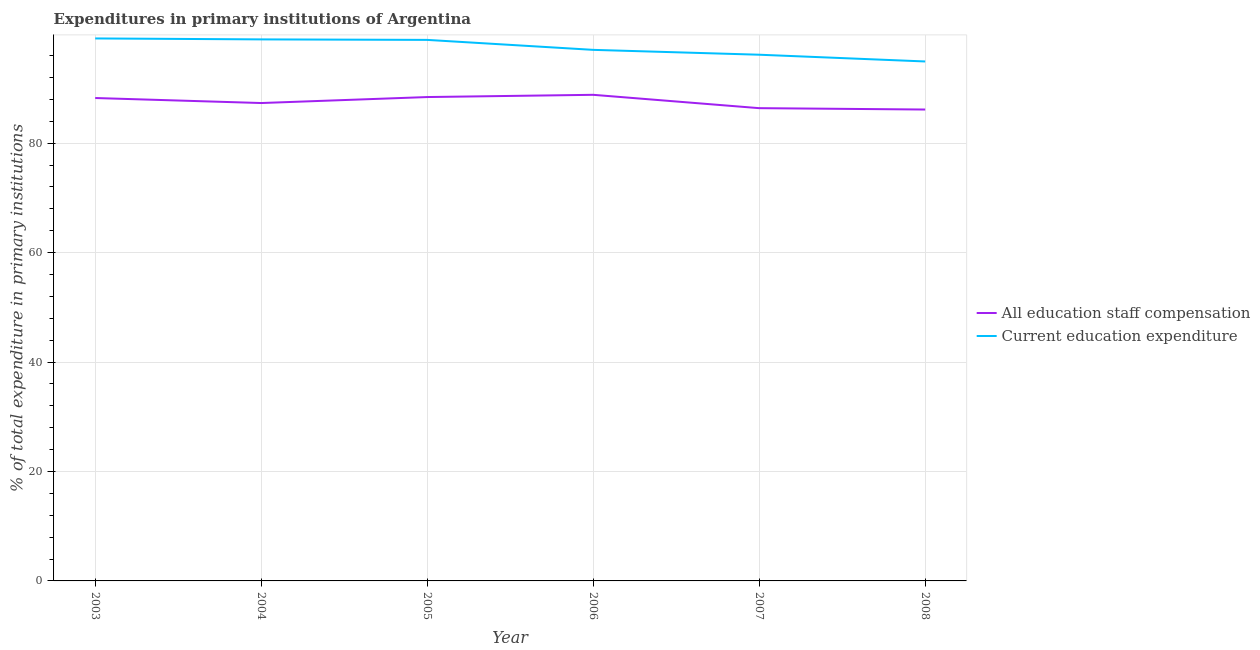Does the line corresponding to expenditure in education intersect with the line corresponding to expenditure in staff compensation?
Your response must be concise. No. Is the number of lines equal to the number of legend labels?
Offer a terse response. Yes. What is the expenditure in education in 2005?
Make the answer very short. 98.88. Across all years, what is the maximum expenditure in education?
Provide a succinct answer. 99.14. Across all years, what is the minimum expenditure in staff compensation?
Offer a very short reply. 86.15. What is the total expenditure in staff compensation in the graph?
Your response must be concise. 525.42. What is the difference between the expenditure in staff compensation in 2004 and that in 2005?
Give a very brief answer. -1.09. What is the difference between the expenditure in staff compensation in 2003 and the expenditure in education in 2005?
Your answer should be very brief. -10.62. What is the average expenditure in education per year?
Keep it short and to the point. 97.52. In the year 2004, what is the difference between the expenditure in education and expenditure in staff compensation?
Keep it short and to the point. 11.63. In how many years, is the expenditure in staff compensation greater than 60 %?
Keep it short and to the point. 6. What is the ratio of the expenditure in education in 2006 to that in 2008?
Provide a succinct answer. 1.02. Is the difference between the expenditure in staff compensation in 2007 and 2008 greater than the difference between the expenditure in education in 2007 and 2008?
Your answer should be compact. No. What is the difference between the highest and the second highest expenditure in staff compensation?
Provide a succinct answer. 0.41. What is the difference between the highest and the lowest expenditure in staff compensation?
Your response must be concise. 2.69. Is the sum of the expenditure in education in 2004 and 2006 greater than the maximum expenditure in staff compensation across all years?
Provide a short and direct response. Yes. Does the expenditure in education monotonically increase over the years?
Your answer should be very brief. No. Is the expenditure in education strictly greater than the expenditure in staff compensation over the years?
Offer a terse response. Yes. How many lines are there?
Make the answer very short. 2. How many years are there in the graph?
Make the answer very short. 6. Are the values on the major ticks of Y-axis written in scientific E-notation?
Offer a very short reply. No. How many legend labels are there?
Make the answer very short. 2. How are the legend labels stacked?
Give a very brief answer. Vertical. What is the title of the graph?
Your response must be concise. Expenditures in primary institutions of Argentina. What is the label or title of the X-axis?
Give a very brief answer. Year. What is the label or title of the Y-axis?
Your answer should be very brief. % of total expenditure in primary institutions. What is the % of total expenditure in primary institutions of All education staff compensation in 2003?
Offer a very short reply. 88.25. What is the % of total expenditure in primary institutions of Current education expenditure in 2003?
Give a very brief answer. 99.14. What is the % of total expenditure in primary institutions of All education staff compensation in 2004?
Offer a terse response. 87.34. What is the % of total expenditure in primary institutions of Current education expenditure in 2004?
Your answer should be very brief. 98.97. What is the % of total expenditure in primary institutions in All education staff compensation in 2005?
Your response must be concise. 88.43. What is the % of total expenditure in primary institutions in Current education expenditure in 2005?
Provide a succinct answer. 98.88. What is the % of total expenditure in primary institutions in All education staff compensation in 2006?
Offer a very short reply. 88.84. What is the % of total expenditure in primary institutions of Current education expenditure in 2006?
Give a very brief answer. 97.06. What is the % of total expenditure in primary institutions of All education staff compensation in 2007?
Your answer should be very brief. 86.4. What is the % of total expenditure in primary institutions of Current education expenditure in 2007?
Provide a short and direct response. 96.17. What is the % of total expenditure in primary institutions in All education staff compensation in 2008?
Ensure brevity in your answer.  86.15. What is the % of total expenditure in primary institutions of Current education expenditure in 2008?
Provide a short and direct response. 94.93. Across all years, what is the maximum % of total expenditure in primary institutions of All education staff compensation?
Offer a terse response. 88.84. Across all years, what is the maximum % of total expenditure in primary institutions of Current education expenditure?
Your answer should be very brief. 99.14. Across all years, what is the minimum % of total expenditure in primary institutions of All education staff compensation?
Provide a short and direct response. 86.15. Across all years, what is the minimum % of total expenditure in primary institutions in Current education expenditure?
Your answer should be compact. 94.93. What is the total % of total expenditure in primary institutions in All education staff compensation in the graph?
Offer a very short reply. 525.42. What is the total % of total expenditure in primary institutions of Current education expenditure in the graph?
Offer a very short reply. 585.15. What is the difference between the % of total expenditure in primary institutions of All education staff compensation in 2003 and that in 2004?
Your answer should be very brief. 0.92. What is the difference between the % of total expenditure in primary institutions in Current education expenditure in 2003 and that in 2004?
Your response must be concise. 0.18. What is the difference between the % of total expenditure in primary institutions in All education staff compensation in 2003 and that in 2005?
Offer a very short reply. -0.18. What is the difference between the % of total expenditure in primary institutions of Current education expenditure in 2003 and that in 2005?
Provide a short and direct response. 0.27. What is the difference between the % of total expenditure in primary institutions in All education staff compensation in 2003 and that in 2006?
Offer a very short reply. -0.59. What is the difference between the % of total expenditure in primary institutions in Current education expenditure in 2003 and that in 2006?
Ensure brevity in your answer.  2.09. What is the difference between the % of total expenditure in primary institutions of All education staff compensation in 2003 and that in 2007?
Provide a short and direct response. 1.85. What is the difference between the % of total expenditure in primary institutions in Current education expenditure in 2003 and that in 2007?
Give a very brief answer. 2.98. What is the difference between the % of total expenditure in primary institutions in All education staff compensation in 2003 and that in 2008?
Your answer should be very brief. 2.1. What is the difference between the % of total expenditure in primary institutions in Current education expenditure in 2003 and that in 2008?
Your answer should be very brief. 4.21. What is the difference between the % of total expenditure in primary institutions in All education staff compensation in 2004 and that in 2005?
Provide a short and direct response. -1.09. What is the difference between the % of total expenditure in primary institutions in Current education expenditure in 2004 and that in 2005?
Give a very brief answer. 0.09. What is the difference between the % of total expenditure in primary institutions in All education staff compensation in 2004 and that in 2006?
Your answer should be compact. -1.5. What is the difference between the % of total expenditure in primary institutions in Current education expenditure in 2004 and that in 2006?
Your response must be concise. 1.91. What is the difference between the % of total expenditure in primary institutions in All education staff compensation in 2004 and that in 2007?
Provide a succinct answer. 0.94. What is the difference between the % of total expenditure in primary institutions of Current education expenditure in 2004 and that in 2007?
Offer a very short reply. 2.8. What is the difference between the % of total expenditure in primary institutions of All education staff compensation in 2004 and that in 2008?
Your response must be concise. 1.19. What is the difference between the % of total expenditure in primary institutions in Current education expenditure in 2004 and that in 2008?
Provide a succinct answer. 4.04. What is the difference between the % of total expenditure in primary institutions in All education staff compensation in 2005 and that in 2006?
Offer a terse response. -0.41. What is the difference between the % of total expenditure in primary institutions in Current education expenditure in 2005 and that in 2006?
Offer a terse response. 1.82. What is the difference between the % of total expenditure in primary institutions in All education staff compensation in 2005 and that in 2007?
Keep it short and to the point. 2.03. What is the difference between the % of total expenditure in primary institutions in Current education expenditure in 2005 and that in 2007?
Your answer should be compact. 2.71. What is the difference between the % of total expenditure in primary institutions of All education staff compensation in 2005 and that in 2008?
Offer a very short reply. 2.28. What is the difference between the % of total expenditure in primary institutions in Current education expenditure in 2005 and that in 2008?
Offer a terse response. 3.95. What is the difference between the % of total expenditure in primary institutions of All education staff compensation in 2006 and that in 2007?
Make the answer very short. 2.44. What is the difference between the % of total expenditure in primary institutions of Current education expenditure in 2006 and that in 2007?
Offer a very short reply. 0.89. What is the difference between the % of total expenditure in primary institutions in All education staff compensation in 2006 and that in 2008?
Offer a terse response. 2.69. What is the difference between the % of total expenditure in primary institutions of Current education expenditure in 2006 and that in 2008?
Offer a terse response. 2.12. What is the difference between the % of total expenditure in primary institutions in All education staff compensation in 2007 and that in 2008?
Provide a short and direct response. 0.25. What is the difference between the % of total expenditure in primary institutions of Current education expenditure in 2007 and that in 2008?
Offer a very short reply. 1.23. What is the difference between the % of total expenditure in primary institutions of All education staff compensation in 2003 and the % of total expenditure in primary institutions of Current education expenditure in 2004?
Keep it short and to the point. -10.71. What is the difference between the % of total expenditure in primary institutions of All education staff compensation in 2003 and the % of total expenditure in primary institutions of Current education expenditure in 2005?
Make the answer very short. -10.62. What is the difference between the % of total expenditure in primary institutions of All education staff compensation in 2003 and the % of total expenditure in primary institutions of Current education expenditure in 2006?
Make the answer very short. -8.8. What is the difference between the % of total expenditure in primary institutions of All education staff compensation in 2003 and the % of total expenditure in primary institutions of Current education expenditure in 2007?
Give a very brief answer. -7.91. What is the difference between the % of total expenditure in primary institutions of All education staff compensation in 2003 and the % of total expenditure in primary institutions of Current education expenditure in 2008?
Provide a succinct answer. -6.68. What is the difference between the % of total expenditure in primary institutions in All education staff compensation in 2004 and the % of total expenditure in primary institutions in Current education expenditure in 2005?
Your answer should be very brief. -11.54. What is the difference between the % of total expenditure in primary institutions in All education staff compensation in 2004 and the % of total expenditure in primary institutions in Current education expenditure in 2006?
Provide a short and direct response. -9.72. What is the difference between the % of total expenditure in primary institutions of All education staff compensation in 2004 and the % of total expenditure in primary institutions of Current education expenditure in 2007?
Provide a short and direct response. -8.83. What is the difference between the % of total expenditure in primary institutions in All education staff compensation in 2004 and the % of total expenditure in primary institutions in Current education expenditure in 2008?
Make the answer very short. -7.6. What is the difference between the % of total expenditure in primary institutions in All education staff compensation in 2005 and the % of total expenditure in primary institutions in Current education expenditure in 2006?
Offer a very short reply. -8.63. What is the difference between the % of total expenditure in primary institutions of All education staff compensation in 2005 and the % of total expenditure in primary institutions of Current education expenditure in 2007?
Keep it short and to the point. -7.74. What is the difference between the % of total expenditure in primary institutions in All education staff compensation in 2005 and the % of total expenditure in primary institutions in Current education expenditure in 2008?
Provide a succinct answer. -6.5. What is the difference between the % of total expenditure in primary institutions in All education staff compensation in 2006 and the % of total expenditure in primary institutions in Current education expenditure in 2007?
Your answer should be compact. -7.33. What is the difference between the % of total expenditure in primary institutions of All education staff compensation in 2006 and the % of total expenditure in primary institutions of Current education expenditure in 2008?
Your answer should be compact. -6.09. What is the difference between the % of total expenditure in primary institutions of All education staff compensation in 2007 and the % of total expenditure in primary institutions of Current education expenditure in 2008?
Make the answer very short. -8.53. What is the average % of total expenditure in primary institutions of All education staff compensation per year?
Keep it short and to the point. 87.57. What is the average % of total expenditure in primary institutions in Current education expenditure per year?
Give a very brief answer. 97.53. In the year 2003, what is the difference between the % of total expenditure in primary institutions in All education staff compensation and % of total expenditure in primary institutions in Current education expenditure?
Your response must be concise. -10.89. In the year 2004, what is the difference between the % of total expenditure in primary institutions of All education staff compensation and % of total expenditure in primary institutions of Current education expenditure?
Offer a terse response. -11.63. In the year 2005, what is the difference between the % of total expenditure in primary institutions in All education staff compensation and % of total expenditure in primary institutions in Current education expenditure?
Offer a terse response. -10.45. In the year 2006, what is the difference between the % of total expenditure in primary institutions of All education staff compensation and % of total expenditure in primary institutions of Current education expenditure?
Provide a succinct answer. -8.22. In the year 2007, what is the difference between the % of total expenditure in primary institutions in All education staff compensation and % of total expenditure in primary institutions in Current education expenditure?
Keep it short and to the point. -9.77. In the year 2008, what is the difference between the % of total expenditure in primary institutions of All education staff compensation and % of total expenditure in primary institutions of Current education expenditure?
Your response must be concise. -8.78. What is the ratio of the % of total expenditure in primary institutions of All education staff compensation in 2003 to that in 2004?
Ensure brevity in your answer.  1.01. What is the ratio of the % of total expenditure in primary institutions in All education staff compensation in 2003 to that in 2005?
Ensure brevity in your answer.  1. What is the ratio of the % of total expenditure in primary institutions of Current education expenditure in 2003 to that in 2005?
Your response must be concise. 1. What is the ratio of the % of total expenditure in primary institutions of Current education expenditure in 2003 to that in 2006?
Provide a short and direct response. 1.02. What is the ratio of the % of total expenditure in primary institutions of All education staff compensation in 2003 to that in 2007?
Your response must be concise. 1.02. What is the ratio of the % of total expenditure in primary institutions of Current education expenditure in 2003 to that in 2007?
Offer a terse response. 1.03. What is the ratio of the % of total expenditure in primary institutions in All education staff compensation in 2003 to that in 2008?
Provide a short and direct response. 1.02. What is the ratio of the % of total expenditure in primary institutions of Current education expenditure in 2003 to that in 2008?
Offer a very short reply. 1.04. What is the ratio of the % of total expenditure in primary institutions of All education staff compensation in 2004 to that in 2005?
Provide a short and direct response. 0.99. What is the ratio of the % of total expenditure in primary institutions of Current education expenditure in 2004 to that in 2005?
Provide a succinct answer. 1. What is the ratio of the % of total expenditure in primary institutions in All education staff compensation in 2004 to that in 2006?
Keep it short and to the point. 0.98. What is the ratio of the % of total expenditure in primary institutions of Current education expenditure in 2004 to that in 2006?
Keep it short and to the point. 1.02. What is the ratio of the % of total expenditure in primary institutions of All education staff compensation in 2004 to that in 2007?
Keep it short and to the point. 1.01. What is the ratio of the % of total expenditure in primary institutions of Current education expenditure in 2004 to that in 2007?
Offer a very short reply. 1.03. What is the ratio of the % of total expenditure in primary institutions in All education staff compensation in 2004 to that in 2008?
Provide a short and direct response. 1.01. What is the ratio of the % of total expenditure in primary institutions of Current education expenditure in 2004 to that in 2008?
Your response must be concise. 1.04. What is the ratio of the % of total expenditure in primary institutions in Current education expenditure in 2005 to that in 2006?
Your answer should be compact. 1.02. What is the ratio of the % of total expenditure in primary institutions of All education staff compensation in 2005 to that in 2007?
Ensure brevity in your answer.  1.02. What is the ratio of the % of total expenditure in primary institutions of Current education expenditure in 2005 to that in 2007?
Make the answer very short. 1.03. What is the ratio of the % of total expenditure in primary institutions in All education staff compensation in 2005 to that in 2008?
Offer a very short reply. 1.03. What is the ratio of the % of total expenditure in primary institutions in Current education expenditure in 2005 to that in 2008?
Ensure brevity in your answer.  1.04. What is the ratio of the % of total expenditure in primary institutions in All education staff compensation in 2006 to that in 2007?
Your response must be concise. 1.03. What is the ratio of the % of total expenditure in primary institutions in Current education expenditure in 2006 to that in 2007?
Your answer should be compact. 1.01. What is the ratio of the % of total expenditure in primary institutions in All education staff compensation in 2006 to that in 2008?
Your answer should be very brief. 1.03. What is the ratio of the % of total expenditure in primary institutions in Current education expenditure in 2006 to that in 2008?
Provide a short and direct response. 1.02. What is the ratio of the % of total expenditure in primary institutions of Current education expenditure in 2007 to that in 2008?
Make the answer very short. 1.01. What is the difference between the highest and the second highest % of total expenditure in primary institutions of All education staff compensation?
Ensure brevity in your answer.  0.41. What is the difference between the highest and the second highest % of total expenditure in primary institutions in Current education expenditure?
Provide a succinct answer. 0.18. What is the difference between the highest and the lowest % of total expenditure in primary institutions of All education staff compensation?
Provide a succinct answer. 2.69. What is the difference between the highest and the lowest % of total expenditure in primary institutions in Current education expenditure?
Offer a terse response. 4.21. 